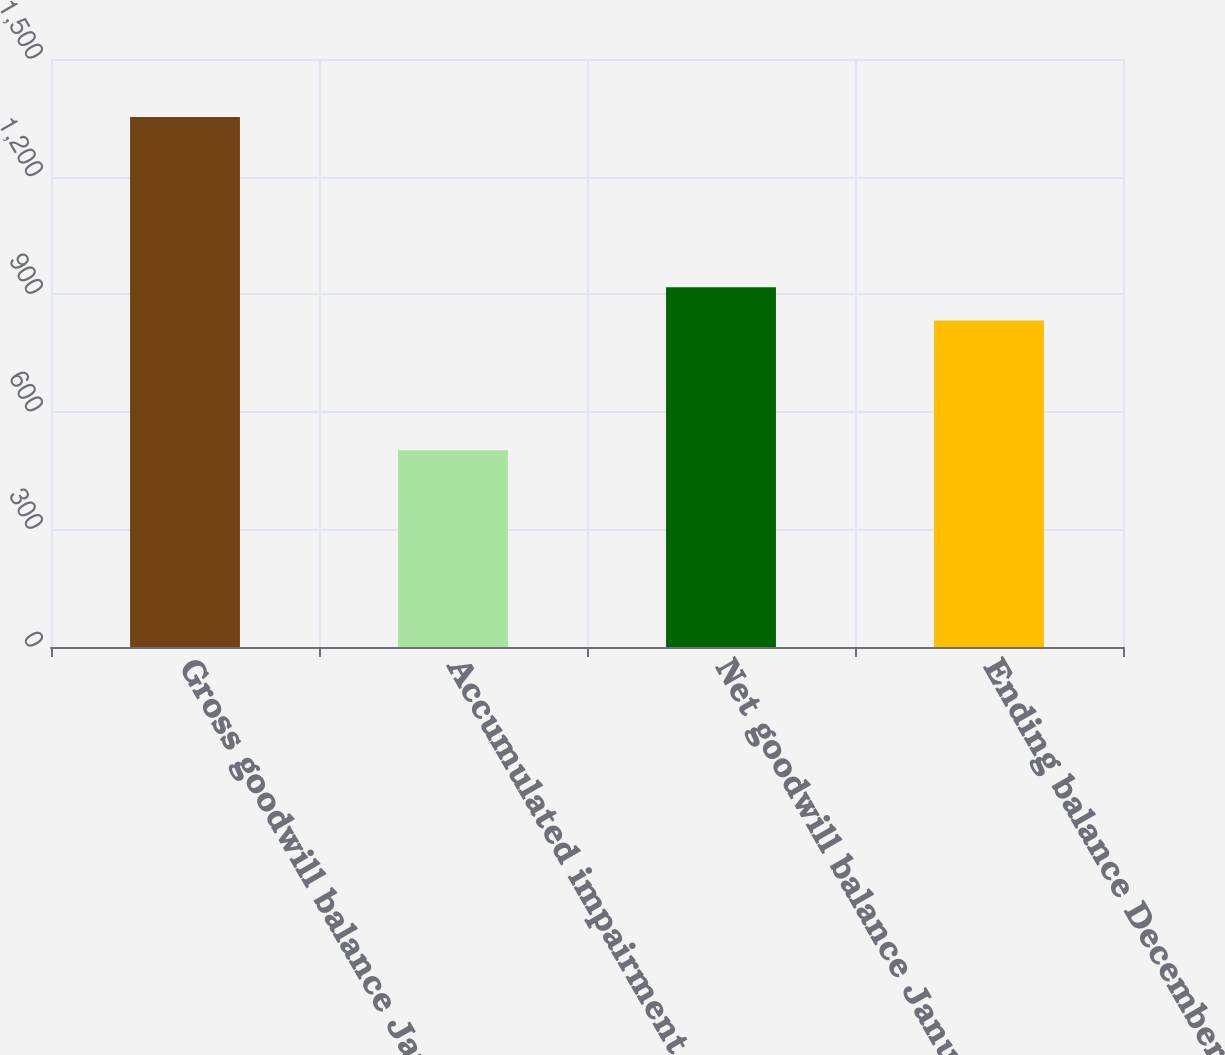Convert chart. <chart><loc_0><loc_0><loc_500><loc_500><bar_chart><fcel>Gross goodwill balance January<fcel>Accumulated impairment losses<fcel>Net goodwill balance January 1<fcel>Ending balance December 31<nl><fcel>1351.9<fcel>501.8<fcel>917.91<fcel>832.9<nl></chart> 